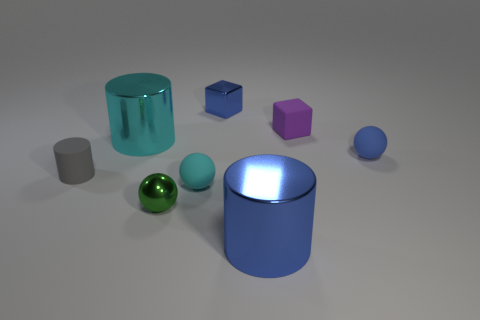Add 1 small brown rubber spheres. How many objects exist? 9 Subtract all blocks. How many objects are left? 6 Add 8 tiny rubber cylinders. How many tiny rubber cylinders exist? 9 Subtract 1 blue cylinders. How many objects are left? 7 Subtract all small blue metallic objects. Subtract all big gray metal cylinders. How many objects are left? 7 Add 8 small shiny balls. How many small shiny balls are left? 9 